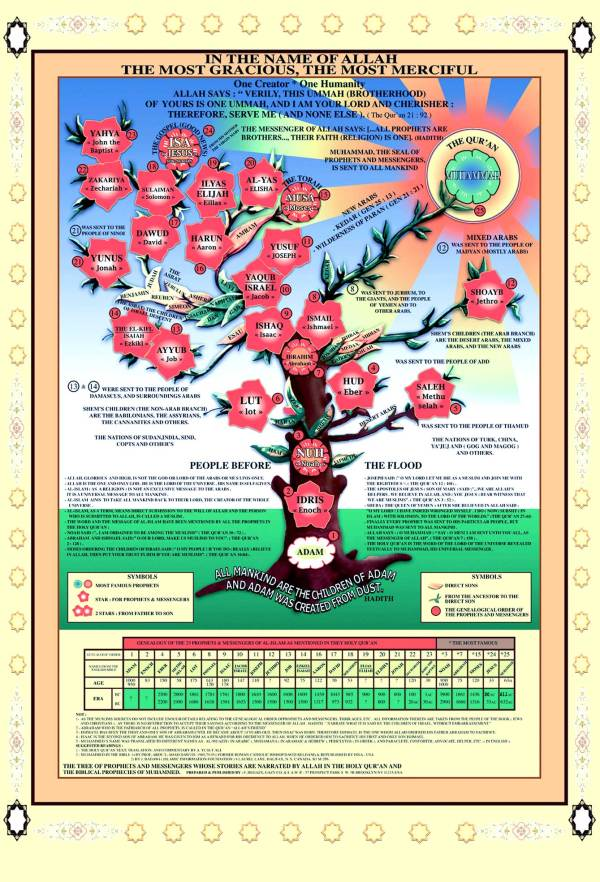How are the names at the bottom of the image related to the content of the tree? The names at the bottom of the image correspond to different nations or peoples mentioned in the Quran and Hadith, who were traditionally believed to have been the audiences to whom these prophets were sent. This part of the chart indexes prophets to these nations, providing a historical and geographical context to their ministries. This ties back to the tree by showing not just the spiritual but also the social and geographic dissemination of their messages across different cultures and eras. 